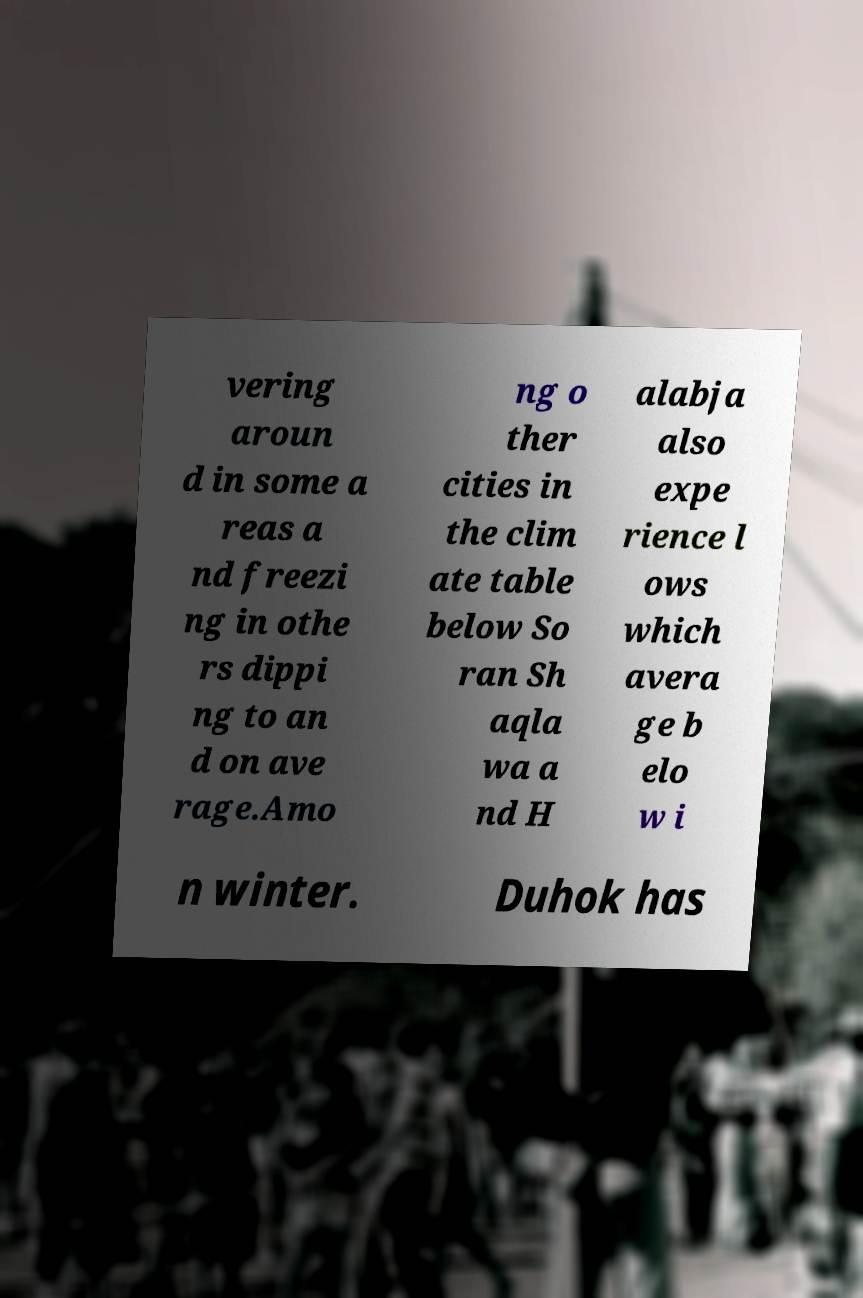There's text embedded in this image that I need extracted. Can you transcribe it verbatim? vering aroun d in some a reas a nd freezi ng in othe rs dippi ng to an d on ave rage.Amo ng o ther cities in the clim ate table below So ran Sh aqla wa a nd H alabja also expe rience l ows which avera ge b elo w i n winter. Duhok has 